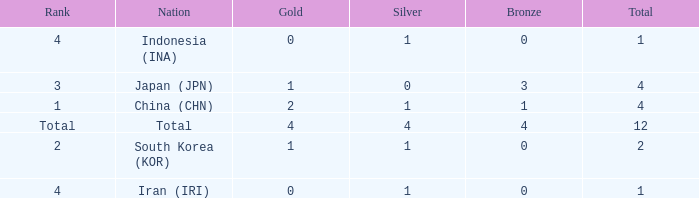How many silver medals for the nation with fewer than 1 golds and total less than 1? 0.0. 